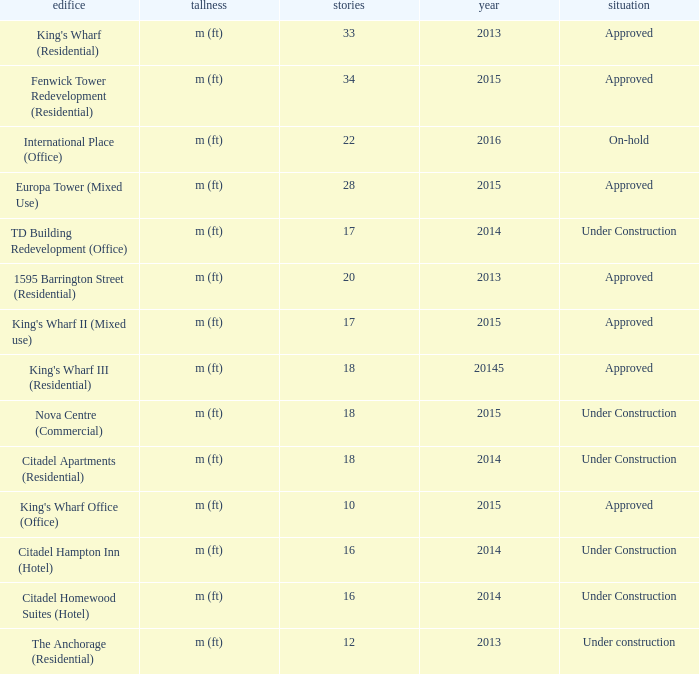Can you parse all the data within this table? {'header': ['edifice', 'tallness', 'stories', 'year', 'situation'], 'rows': [["King's Wharf (Residential)", 'm (ft)', '33', '2013', 'Approved'], ['Fenwick Tower Redevelopment (Residential)', 'm (ft)', '34', '2015', 'Approved'], ['International Place (Office)', 'm (ft)', '22', '2016', 'On-hold'], ['Europa Tower (Mixed Use)', 'm (ft)', '28', '2015', 'Approved'], ['TD Building Redevelopment (Office)', 'm (ft)', '17', '2014', 'Under Construction'], ['1595 Barrington Street (Residential)', 'm (ft)', '20', '2013', 'Approved'], ["King's Wharf II (Mixed use)", 'm (ft)', '17', '2015', 'Approved'], ["King's Wharf III (Residential)", 'm (ft)', '18', '20145', 'Approved'], ['Nova Centre (Commercial)', 'm (ft)', '18', '2015', 'Under Construction'], ['Citadel Apartments (Residential)', 'm (ft)', '18', '2014', 'Under Construction'], ["King's Wharf Office (Office)", 'm (ft)', '10', '2015', 'Approved'], ['Citadel Hampton Inn (Hotel)', 'm (ft)', '16', '2014', 'Under Construction'], ['Citadel Homewood Suites (Hotel)', 'm (ft)', '16', '2014', 'Under Construction'], ['The Anchorage (Residential)', 'm (ft)', '12', '2013', 'Under construction']]} What are the number of floors for the building of td building redevelopment (office)? 17.0. 